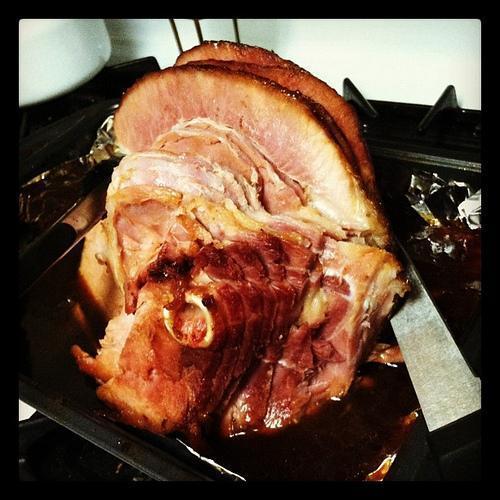How many hams are there?
Give a very brief answer. 1. 